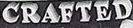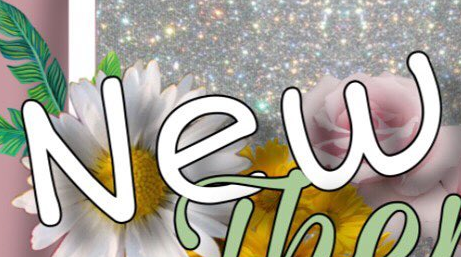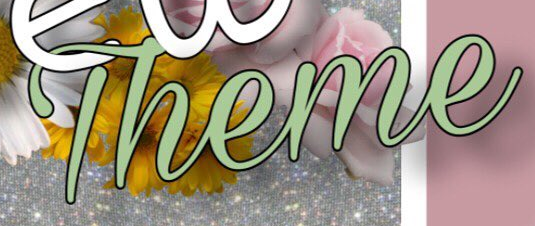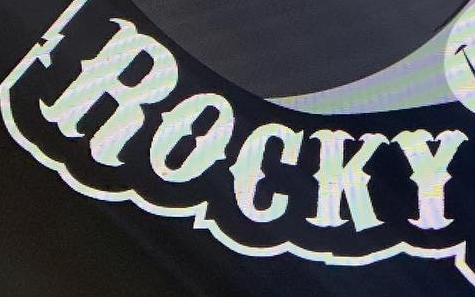What words are shown in these images in order, separated by a semicolon? CRAFTED; New; Theme; ROCKY 